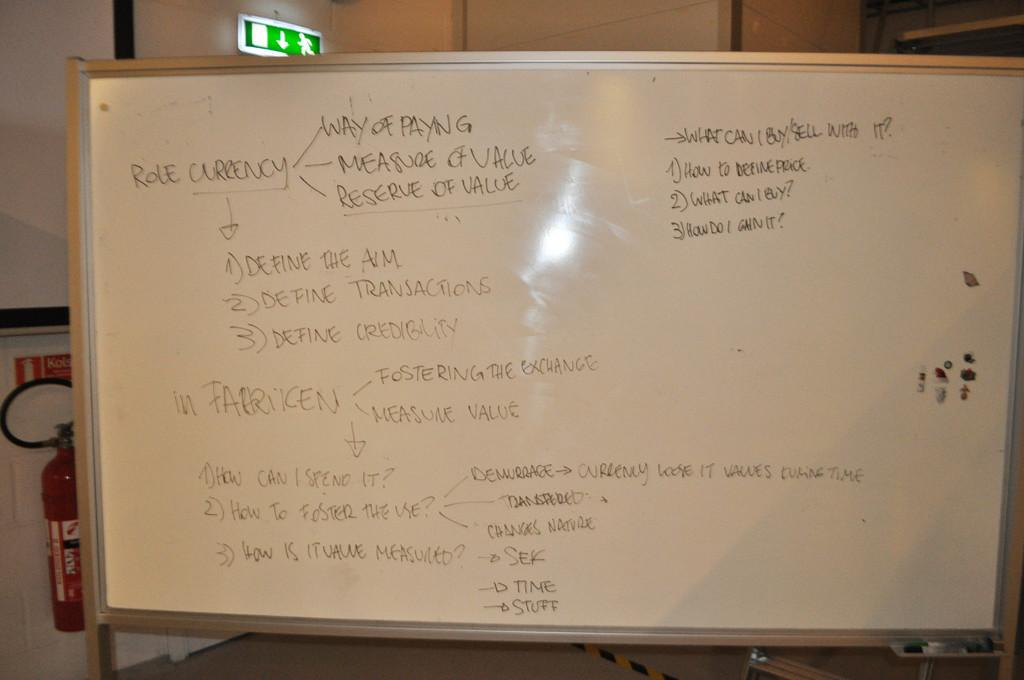<image>
Share a concise interpretation of the image provided. A whiteboard with topics regarding the role currency 